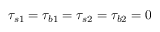<formula> <loc_0><loc_0><loc_500><loc_500>\tau _ { s 1 } = \tau _ { b 1 } = \tau _ { s 2 } = \tau _ { b 2 } = 0</formula> 